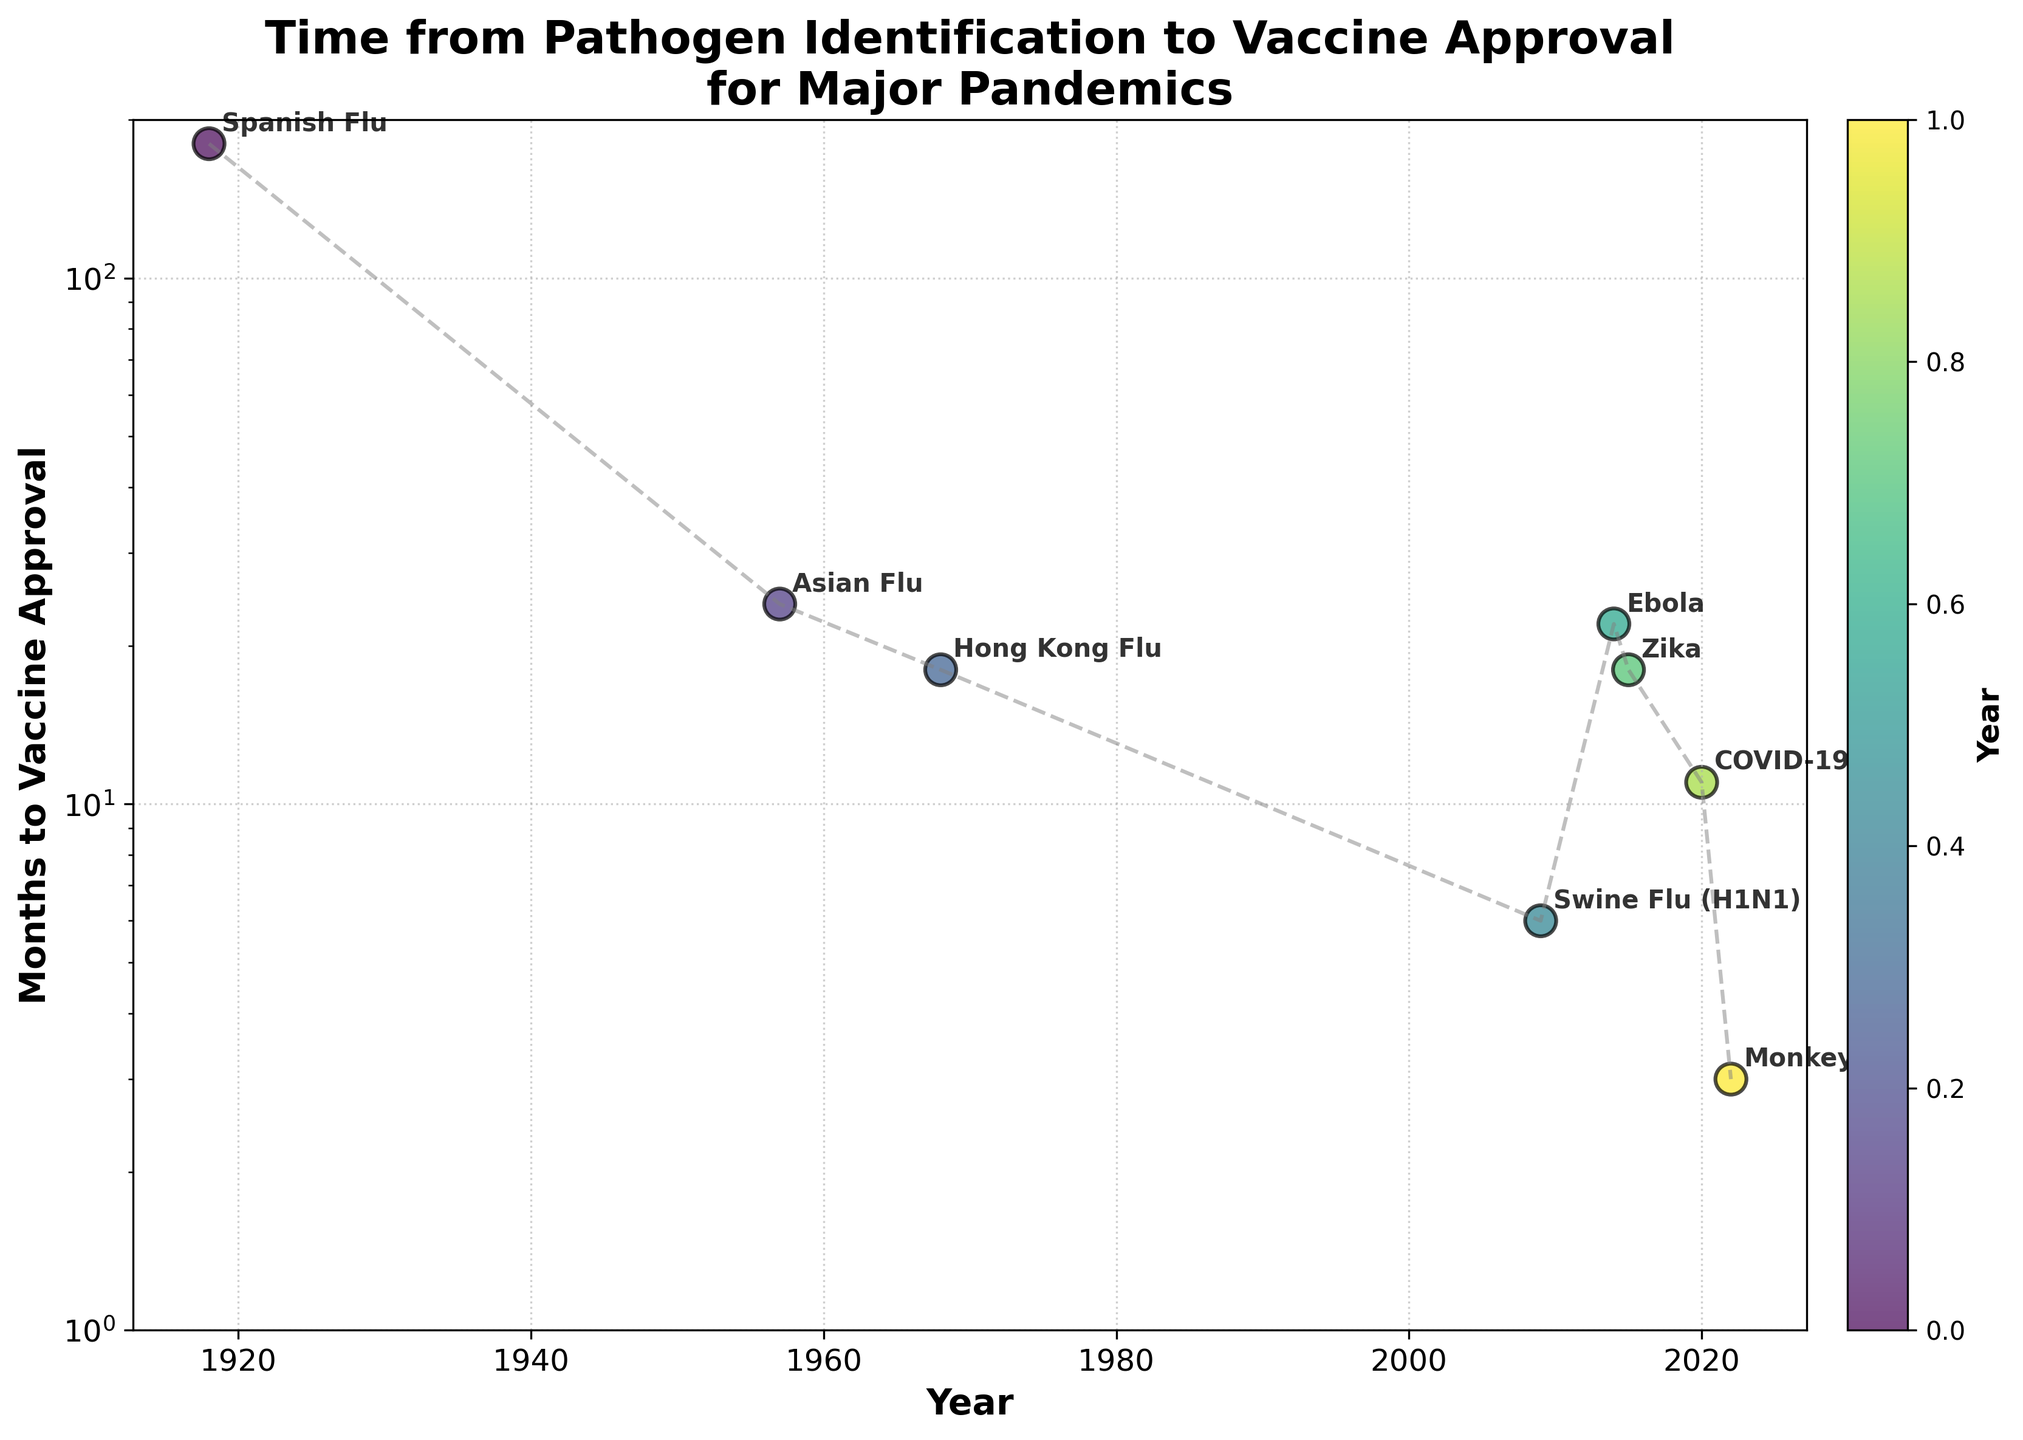What was the time taken from pathogen identification to vaccine approval for the Spanish Flu? The point on the graph for the Spanish Flu (1918) shows a vertical coordinate of 180 months, indicating the time taken for vaccine approval.
Answer: 180 months Which pandemic had the shortest time to vaccine approval? Looking at the y-coordinates of the points, the Monkeypox pandemic (2022) has the smallest y-coordinate, indicating the shortest time to vaccine approval of 3 months.
Answer: Monkeypox How many pandemics had a vaccine approval time of 6 months or less? Identify the points with y-coordinates at or below 6 months: Swine Flu (6 months) and Monkeypox (3 months). Hence, there are 2 pandemics.
Answer: 2 What is the median number of months to vaccine approval among the listed pandemics? Order the months to vaccine approval: 3, 6, 11, 18, 18, 22, 24, 180. The median is the average of the two middle numbers (18 and 18). Therefore, the median is (18+18)/2 = 18 months.
Answer: 18 months Which two pandemics had the exact same time from pathogen identification to vaccine approval, and what was that time? By examining the y-coordinates, both the Hong Kong Flu (1968) and Zika (2015) have the same vertical coordinate at 18 months.
Answer: Hong Kong Flu and Zika, 18 months What trend can you observe in the time taken to develop a vaccine from the Spanish Flu to Monkeypox? Tracking the line connecting the points from 1918 to 2022, there's a general downward trend, indicating that the time to develop vaccines has decreased.
Answer: Decreasing trend For which pandemic did the vaccine approval time significantly deviate from the general trend observed? The Ebola outbreak (2014) point stands out as it has a higher y-coordinate (22 months) compared to the downward trend seen in neighboring points like Swine Flu (2009) and Zika (2015).
Answer: Ebola What is the difference in months taken for vaccine approval between COVID-19 and the Spanish Flu? Locate the points for COVID-19 (11 months) and Spanish Flu (180 months). The difference is 180 - 11 = 169 months.
Answer: 169 months 